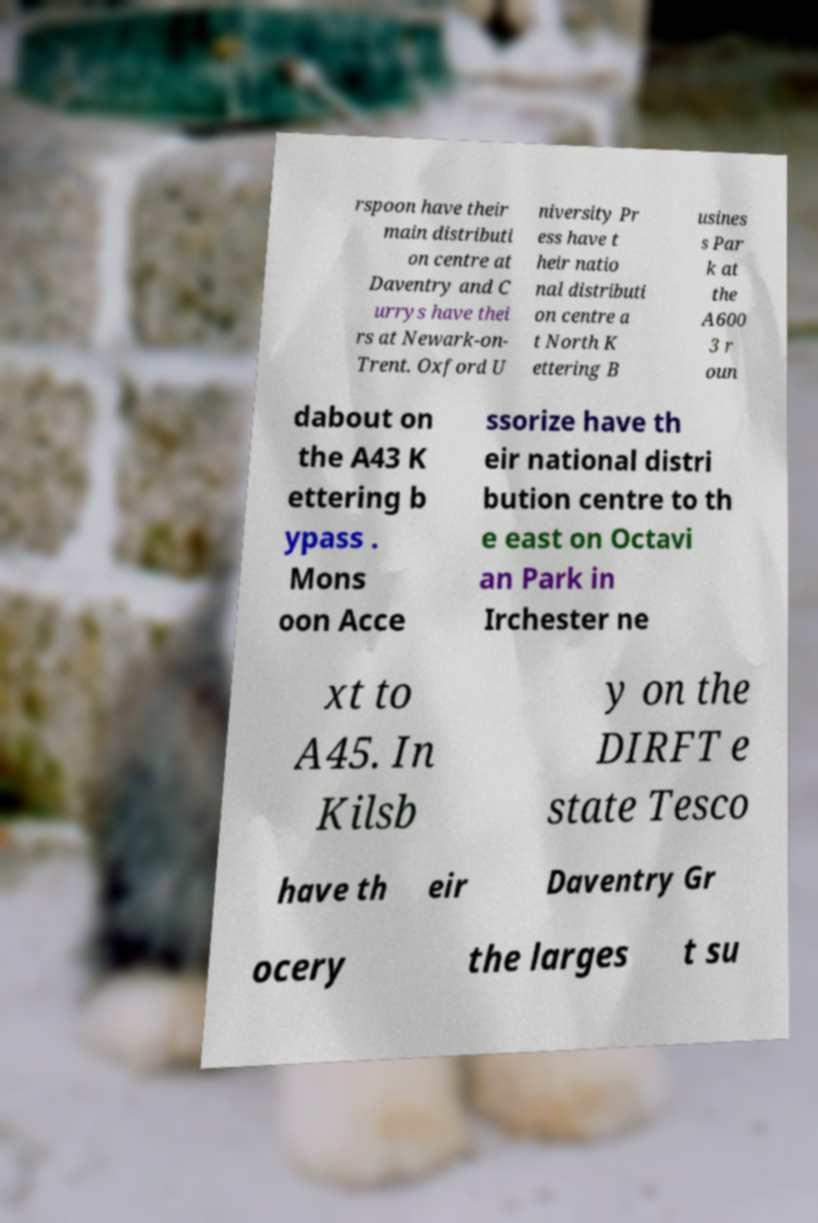Can you read and provide the text displayed in the image?This photo seems to have some interesting text. Can you extract and type it out for me? rspoon have their main distributi on centre at Daventry and C urrys have thei rs at Newark-on- Trent. Oxford U niversity Pr ess have t heir natio nal distributi on centre a t North K ettering B usines s Par k at the A600 3 r oun dabout on the A43 K ettering b ypass . Mons oon Acce ssorize have th eir national distri bution centre to th e east on Octavi an Park in Irchester ne xt to A45. In Kilsb y on the DIRFT e state Tesco have th eir Daventry Gr ocery the larges t su 